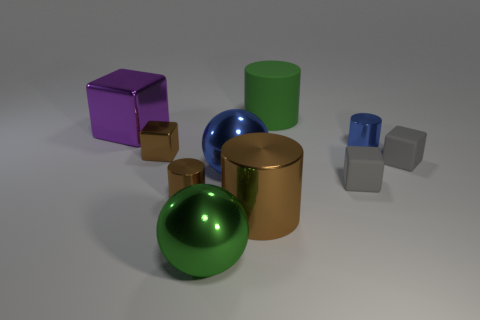Is the blue ball made of the same material as the big cylinder to the left of the green matte thing?
Make the answer very short. Yes. What color is the tiny shiny thing that is to the right of the small brown metal cylinder?
Your response must be concise. Blue. There is a small brown block in front of the green cylinder; are there any brown shiny objects in front of it?
Make the answer very short. Yes. There is a tiny cylinder that is to the right of the big metallic cylinder; is it the same color as the tiny metal cylinder that is left of the large rubber thing?
Give a very brief answer. No. How many small rubber things are behind the small brown cylinder?
Ensure brevity in your answer.  2. How many objects have the same color as the matte cylinder?
Keep it short and to the point. 1. Are the brown block that is on the left side of the big green shiny ball and the big brown cylinder made of the same material?
Ensure brevity in your answer.  Yes. What number of blue cylinders are the same material as the big block?
Provide a succinct answer. 1. Is the number of large matte things to the left of the brown shiny cube greater than the number of blue shiny things?
Make the answer very short. No. There is a metallic thing that is the same color as the rubber cylinder; what is its size?
Your answer should be compact. Large. 